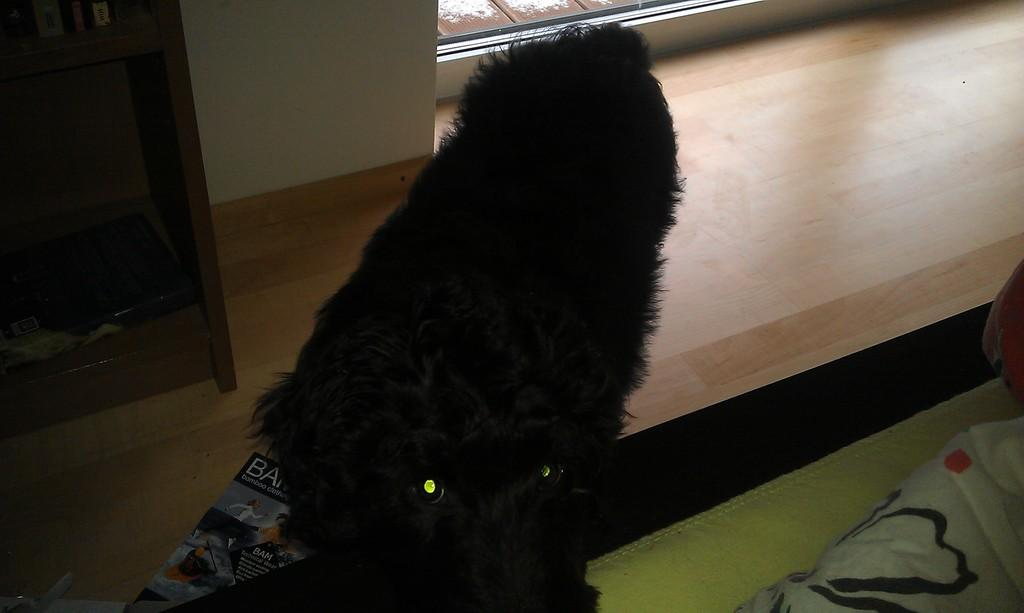What type of animal is in the foreground of the image? There is a black color animal in the foreground of the image. Can you describe any objects or structures near the animal? There is no information about objects or structures near the animal. What is located on the left side of the image? There is a table on the left side of the image. What type of goose is sitting on the zinc table in the image? There is no goose or zinc table present in the image. How many times is the animal pushing the table in the image? There is no information about the animal pushing the table in the image. 